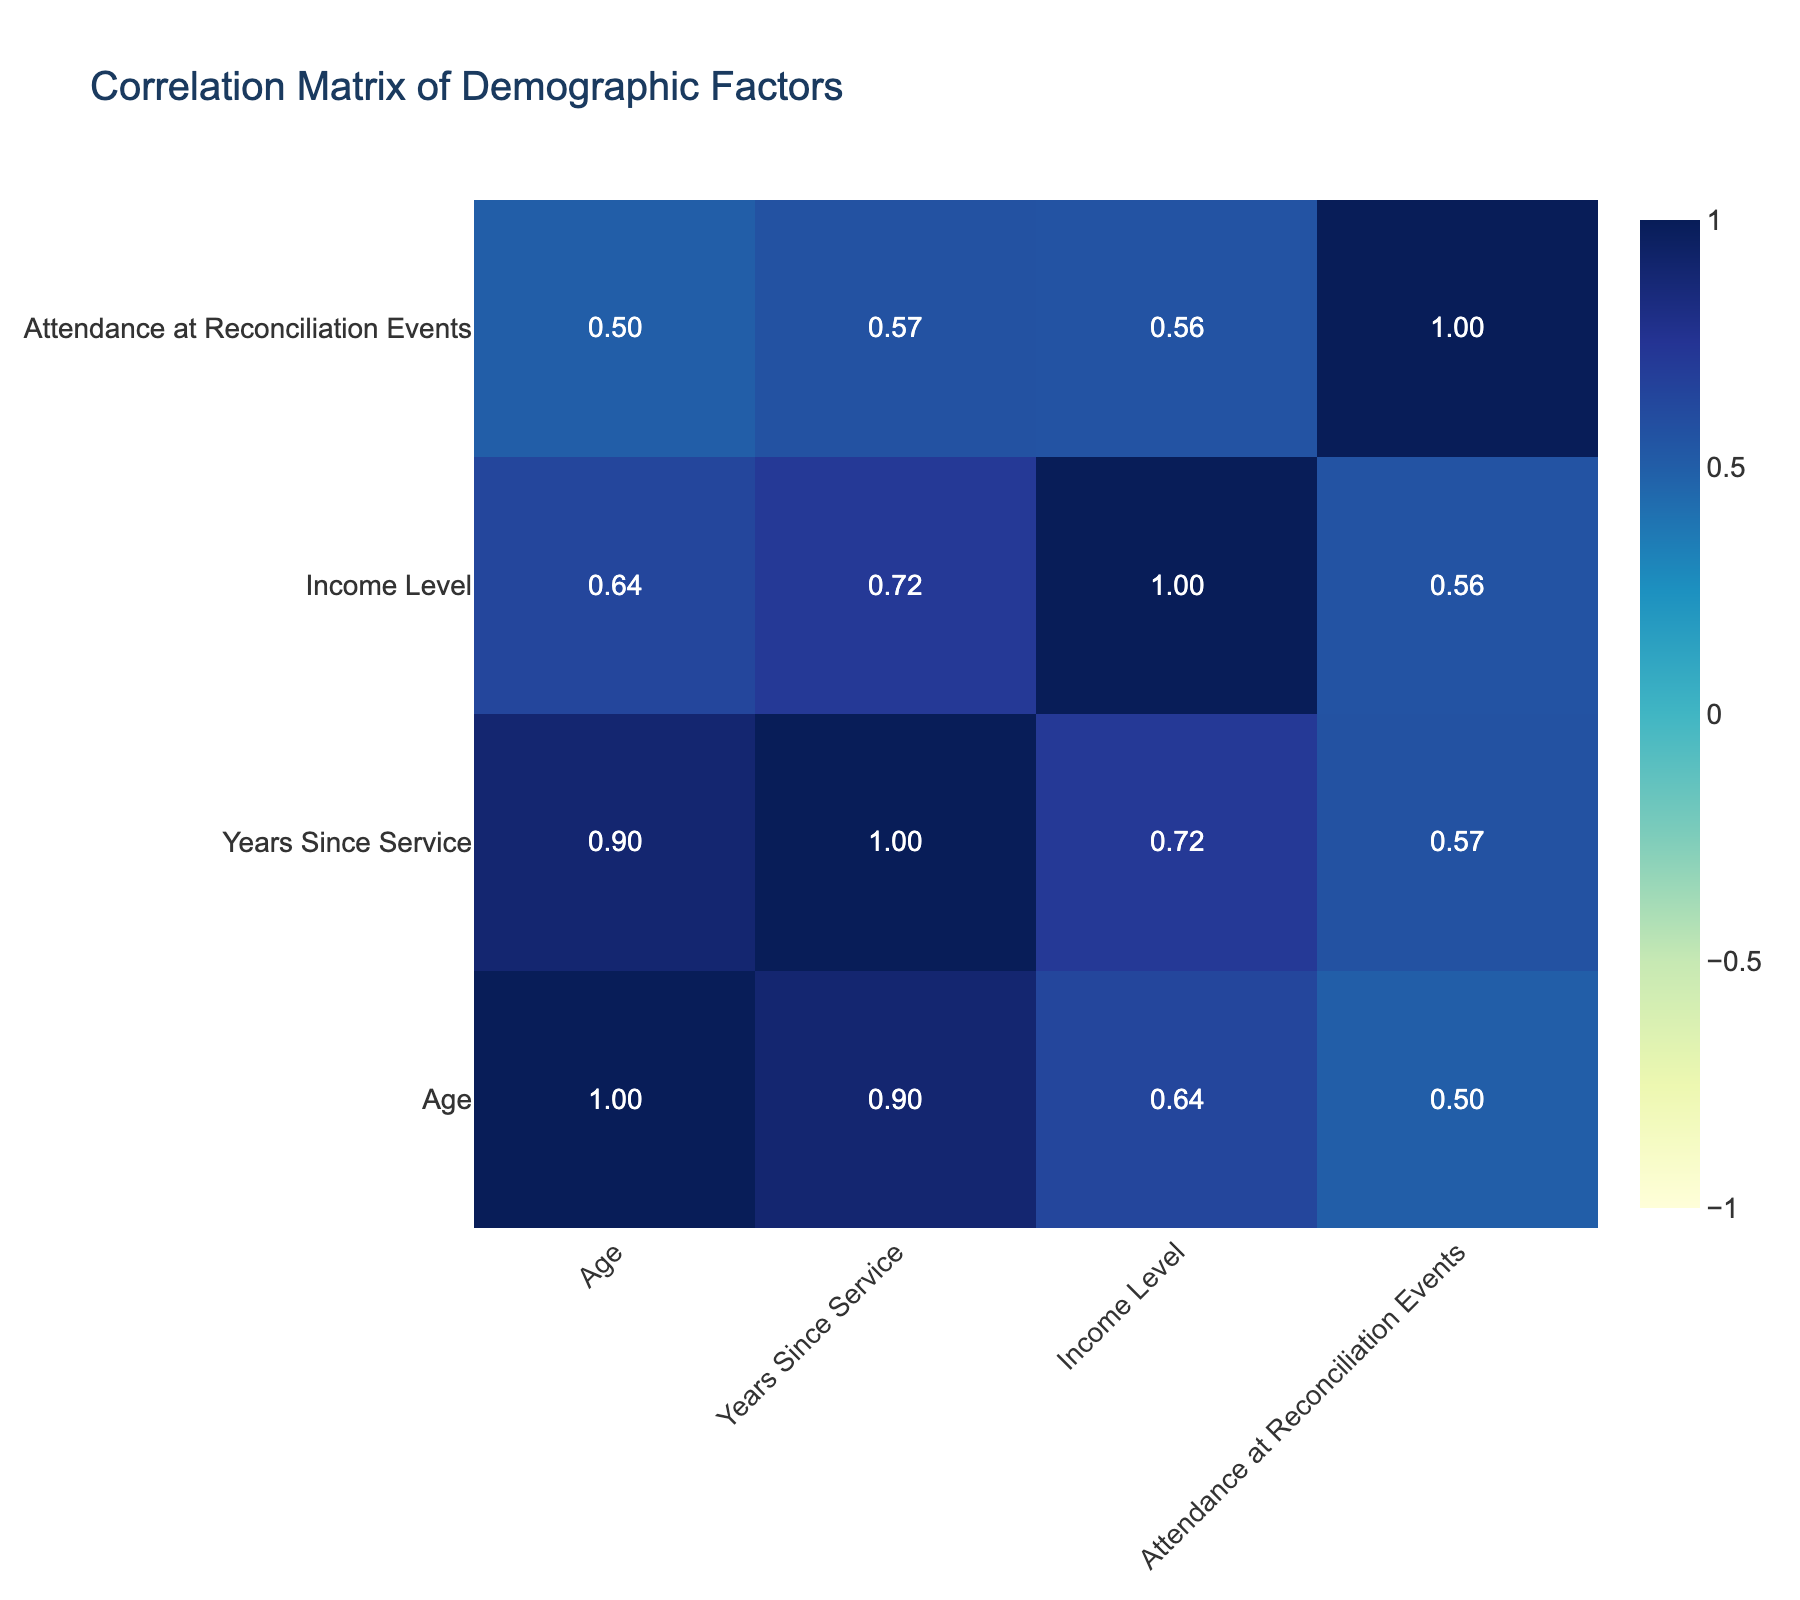What is the correlation between Age and Attendance at Reconciliation Events? The correlation value from the table for Age and Attendance is approximately -0.30, meaning there is a weak negative correlation. As age increases, attendance tends to decrease slightly.
Answer: -0.30 Is there a strong correlation between Income Level and Attendance at Reconciliation Events? The table shows a correlation value of around 0.60 between Income Level and Attendance. This indicates a moderate positive correlation; as income increases, attendance at events tends to increase as well.
Answer: Yes What is the average number of years since service for attendees at reconciliation events? To find the average for attendees, we sum the years since service for attendees (5, 3, 20, 15, 30, 25) which equals 98. Since there are 6 attendees, the average is 98/6 = 16.33.
Answer: 16.33 Does being unemployed correlate with higher attendance at reconciliation events? The correlation between Employment Status (unemployed) and Attendance shows a value of 0.00, indicating no correlation. Thus, being unemployed does not correlate with attendance at events.
Answer: No What is the total income level of attendees at reconciliation events? The attendees' incomes are 45000, 35000, 50000, 60000, 52000, and 70000. The total income is calculated as 45000 + 35000 + 50000 + 60000 + 52000 + 70000, which equals 307000.
Answer: 307000 What pattern do you observe between Gender and Attendance at Reconciliation Events? The correlation value between Gender and Attendance is 0.15. This suggests a very weak correlation, indicating that gender does not have a significant pattern affecting attendance at events.
Answer: No significant pattern What is the median age of the attendees at reconciliation events? The attendees are 35, 28, 55, 60, 46, and 42. Arranging these ages gives us 28, 35, 42, 46, 55, 60. Since there’s an even number of attendees (6), the median is the average of the two middle numbers (42 + 46)/2 = 44.
Answer: 44 Are all attendees from urban locations? The locations listed are Berlin, Hamburg, Frankfurt, Düsseldorf, Stuttgart, Cologne, Munich, Dresden, Hannover, and Bremen, all of which are urban areas in Germany. Therefore, yes, all attendees are from urban locations.
Answer: Yes Is there a correlation between Years Since Service and Employment Status among the attendees? The table indicates a correlation of -0.45 between Years Since Service and Employment Status. This negative correlation suggests that as years since service increases, the likelihood of being employed tends to decrease.
Answer: Yes 